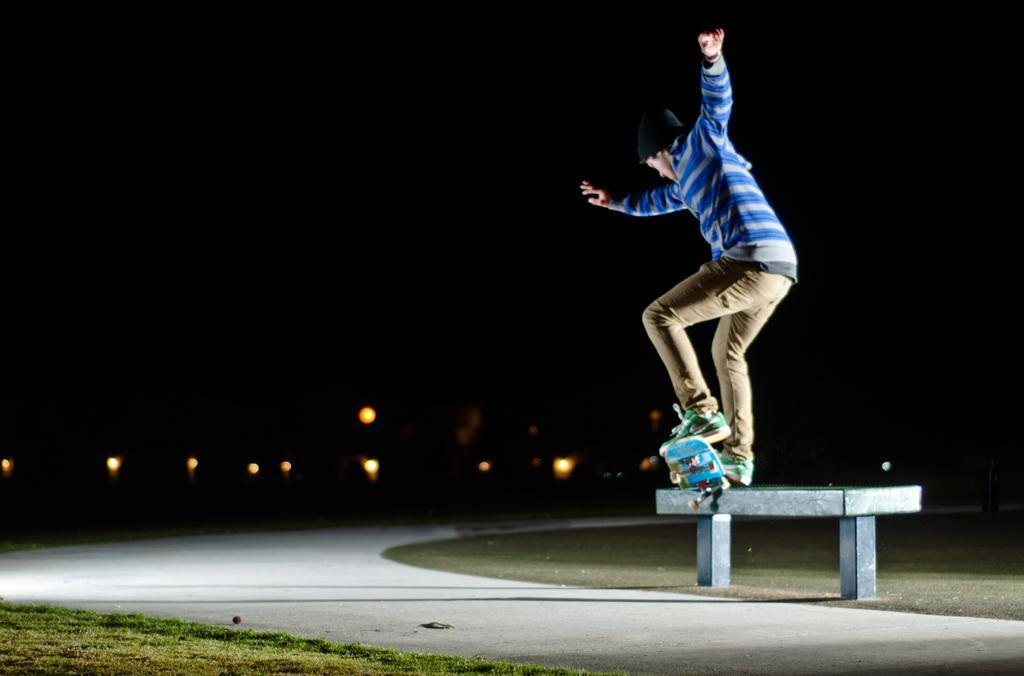Can you describe this image briefly? In the image we can see a person wearing clothes, cap and shoes. Here we can see a skateboard, road, grass, bench, light and a dark sky. 